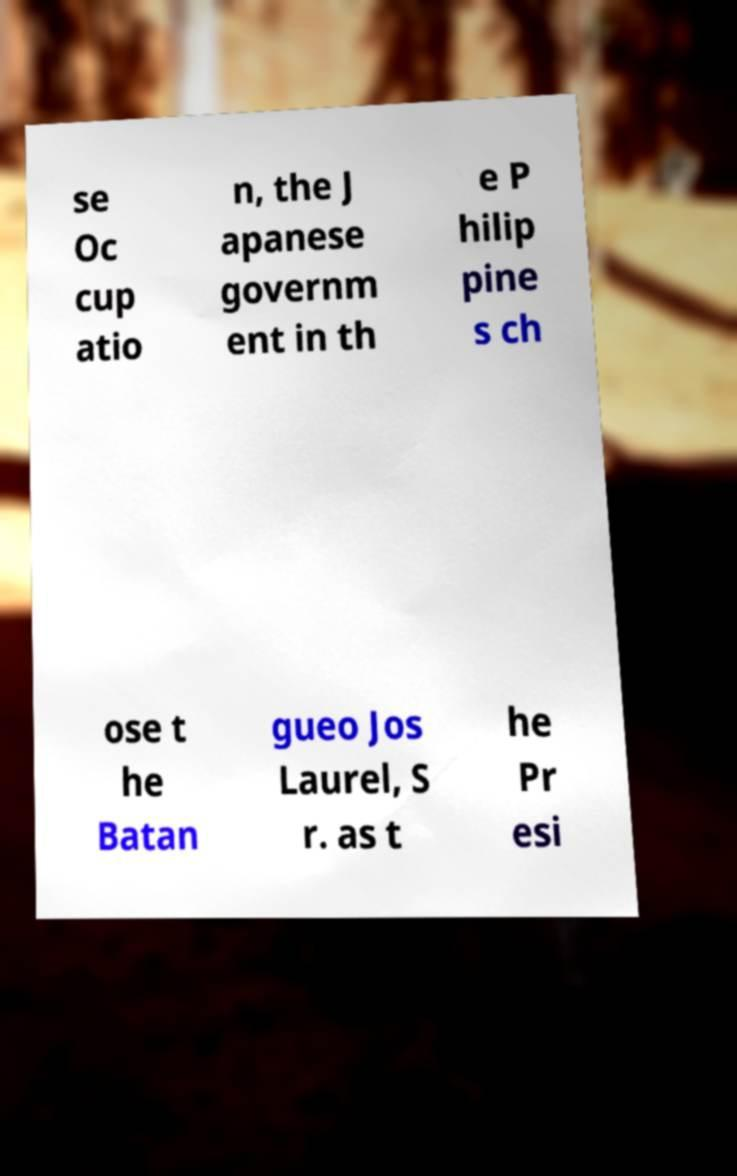Please identify and transcribe the text found in this image. se Oc cup atio n, the J apanese governm ent in th e P hilip pine s ch ose t he Batan gueo Jos Laurel, S r. as t he Pr esi 